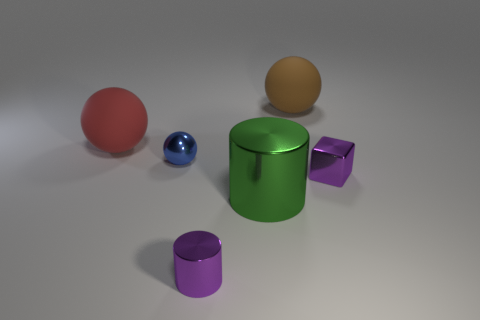Are there more large red things right of the small blue shiny object than large green metallic blocks?
Your response must be concise. No. What number of other green cylinders are the same size as the green metallic cylinder?
Your answer should be very brief. 0. The thing that is the same color as the cube is what size?
Ensure brevity in your answer.  Small. What number of objects are green metal spheres or things that are behind the tiny purple block?
Provide a succinct answer. 3. What is the color of the big object that is behind the tiny block and in front of the large brown thing?
Your answer should be compact. Red. Is the size of the cube the same as the brown ball?
Offer a very short reply. No. There is a sphere on the left side of the blue object; what is its color?
Give a very brief answer. Red. Is there a tiny thing that has the same color as the tiny cube?
Your response must be concise. Yes. What color is the sphere that is the same size as the block?
Provide a short and direct response. Blue. Does the large brown matte thing have the same shape as the blue shiny thing?
Your answer should be compact. Yes. 